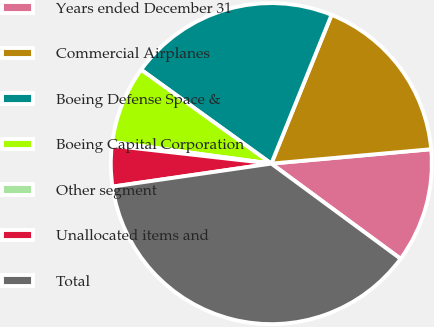<chart> <loc_0><loc_0><loc_500><loc_500><pie_chart><fcel>Years ended December 31<fcel>Commercial Airplanes<fcel>Boeing Defense Space &<fcel>Boeing Capital Corporation<fcel>Other segment<fcel>Unallocated items and<fcel>Total<nl><fcel>11.53%<fcel>17.45%<fcel>21.18%<fcel>7.8%<fcel>0.35%<fcel>4.08%<fcel>37.61%<nl></chart> 